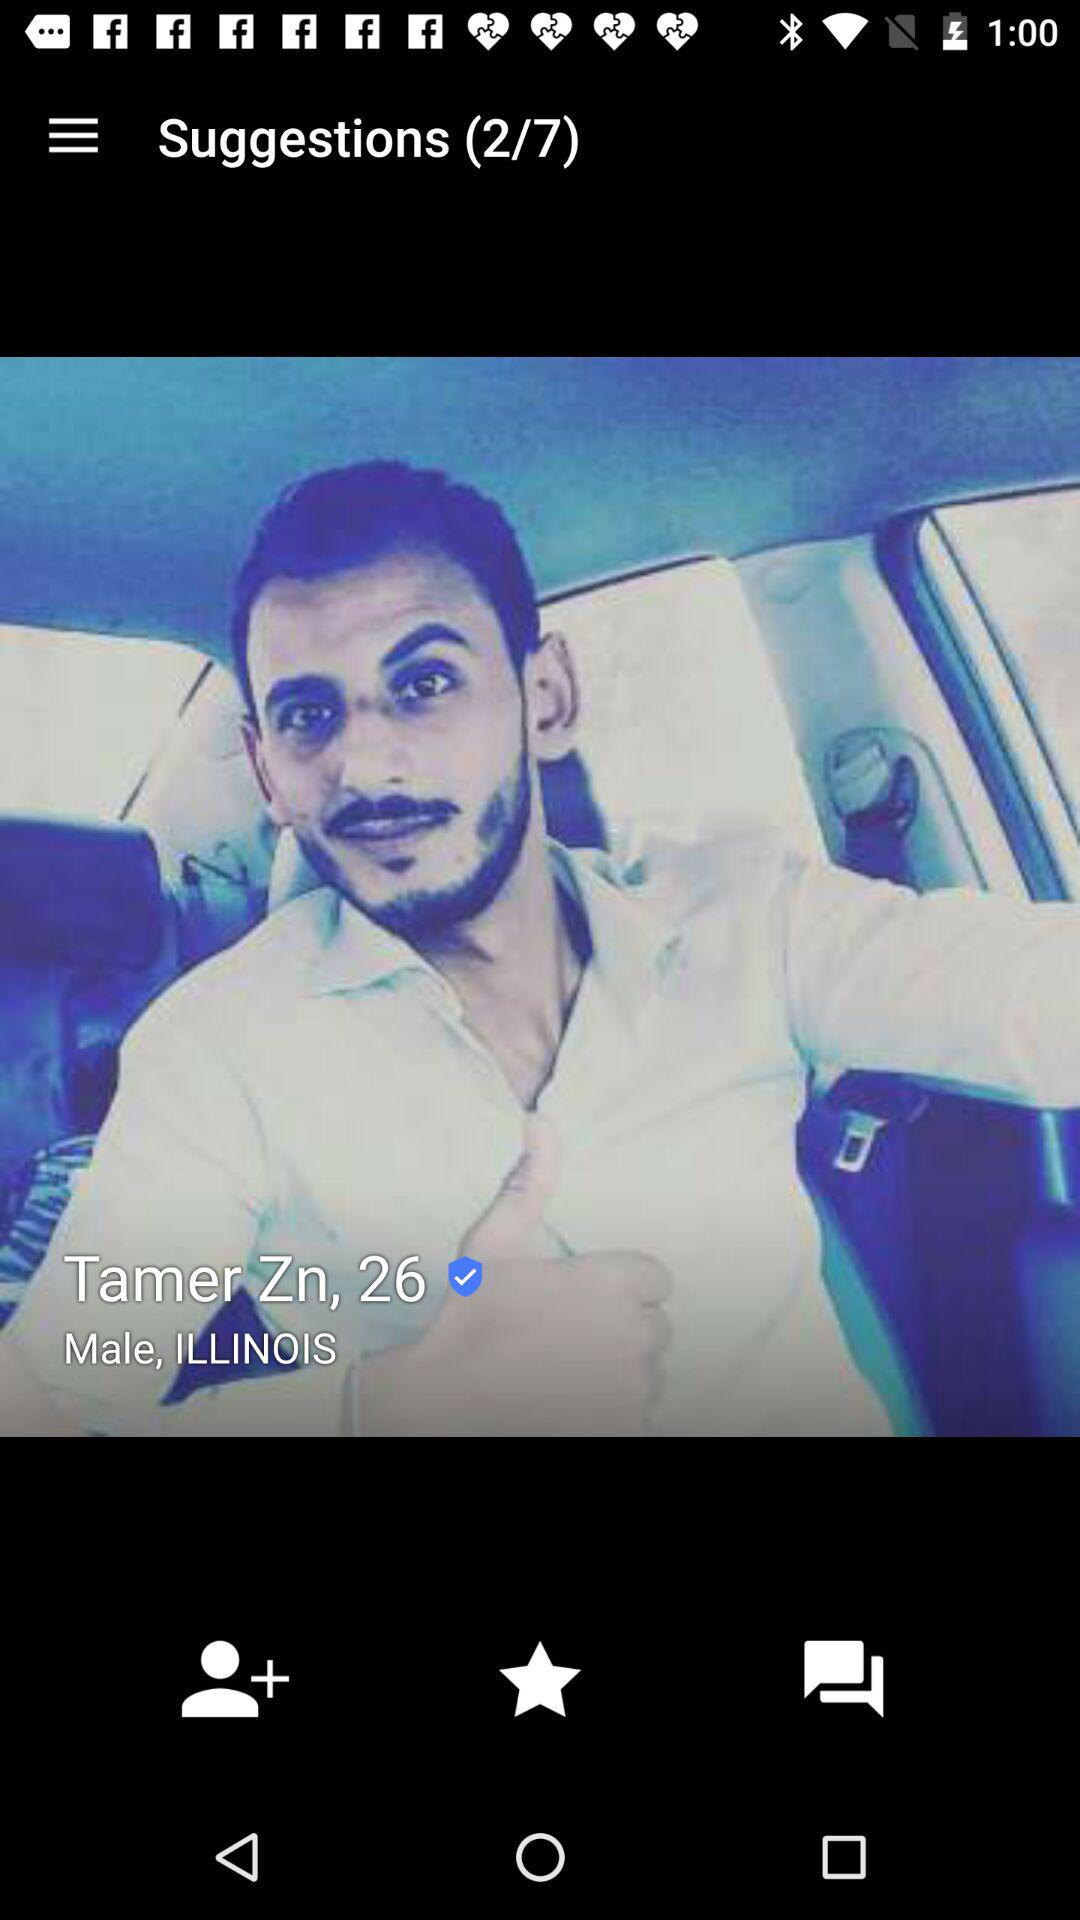What is the gender? The gender is "Male". 